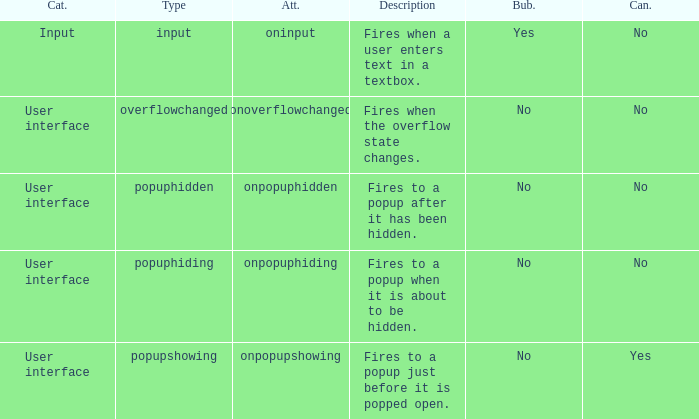What's the attribute with cancelable being yes Onpopupshowing. 